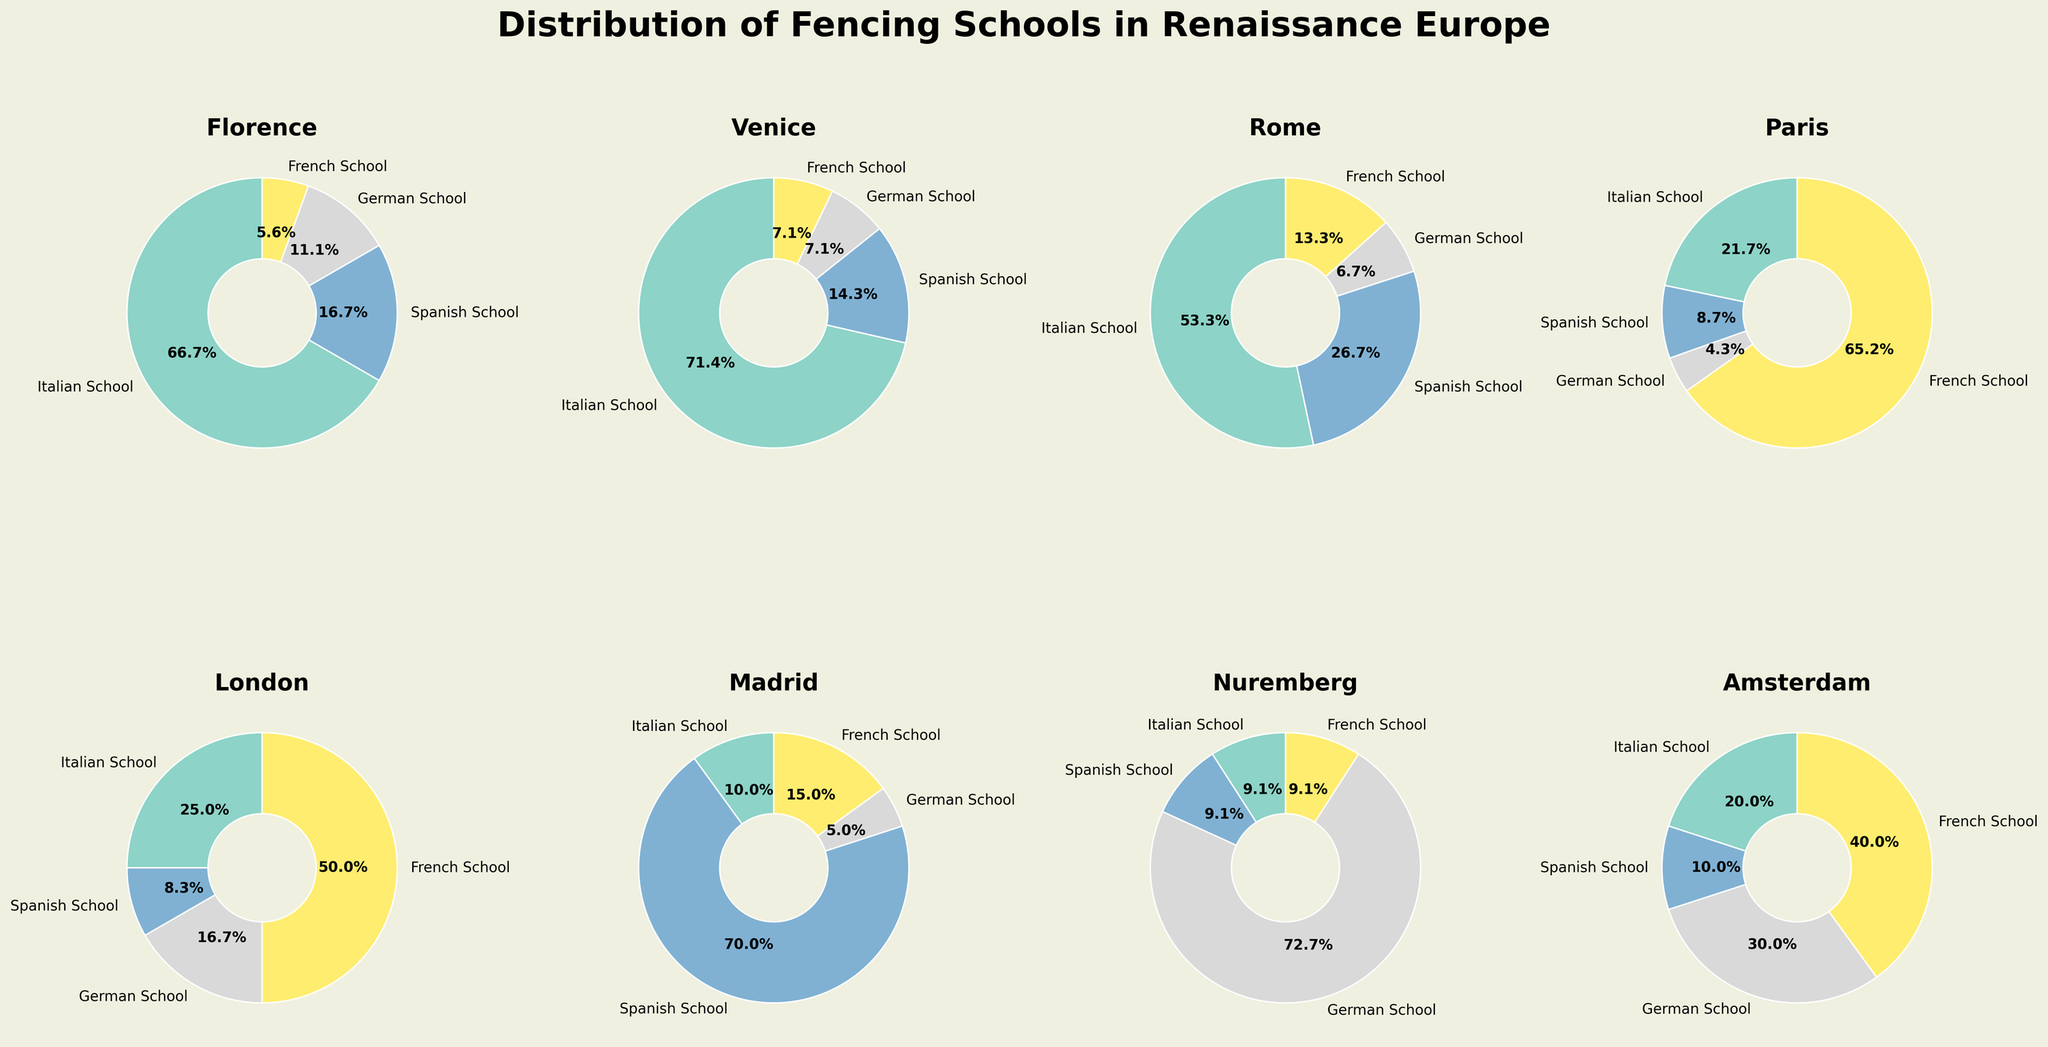What city has the highest percentage of French fencing schools? By looking at the pie charts and focusing on the segments labeled "French School," Paris stands out with a significantly larger section compared to other cities.
Answer: Paris In which city are Spanish fencing schools more numerous than all other school types combined? The chart for Madrid shows that the Spanish School segment is significantly larger than the combined segments of the other schools.
Answer: Madrid What's the total number of fencing schools in Florence based on the chart? Sum the segments for Florence: Italian School (12), Spanish School (3), German School (2), and French School (1). 12 + 3 + 2 + 1 = 18.
Answer: 18 Which city has the smallest proportion of German fencing schools? By comparing the smallest “German School” segments, Venice and Rome each have a small similar segment representing 1 German School out of their total schools.
Answer: Venice or Rome Which city has the greatest diversity in terms of the number of different fencing schools? A city with all four school types represented almost equally would indicate diversity. Paris and Amsterdam both have all four types, but Paris has 15 French Schools dominating. Amsterdam has a more balanced composition.
Answer: Amsterdam How many more Italian schools are there in Florence than in Paris? Italian schools in Florence are 12 and in Paris are 5. To find the difference, subtract: 12 - 5 = 7.
Answer: 7 Which city has a single-digit representation for each school type? By checking the pie charts, Florence, Venice, Rome, London, and Amsterdam all have single-digit values for each school type.
Answer: Florence, Venice, Rome, London, Amsterdam Among the cities with German schools, which city has the largest number of German fencing schools? Nuremberg has the largest segment for "German School" with 8 schools.
Answer: Nuremberg 